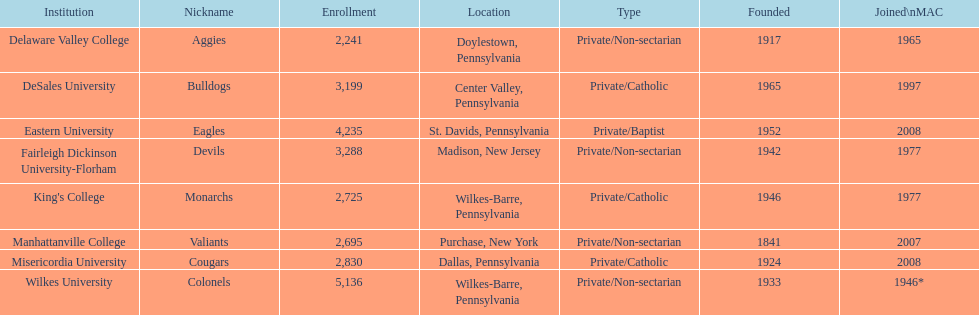Name each institution with enrollment numbers above 4,000? Eastern University, Wilkes University. Parse the full table. {'header': ['Institution', 'Nickname', 'Enrollment', 'Location', 'Type', 'Founded', 'Joined\\nMAC'], 'rows': [['Delaware Valley College', 'Aggies', '2,241', 'Doylestown, Pennsylvania', 'Private/Non-sectarian', '1917', '1965'], ['DeSales University', 'Bulldogs', '3,199', 'Center Valley, Pennsylvania', 'Private/Catholic', '1965', '1997'], ['Eastern University', 'Eagles', '4,235', 'St. Davids, Pennsylvania', 'Private/Baptist', '1952', '2008'], ['Fairleigh Dickinson University-Florham', 'Devils', '3,288', 'Madison, New Jersey', 'Private/Non-sectarian', '1942', '1977'], ["King's College", 'Monarchs', '2,725', 'Wilkes-Barre, Pennsylvania', 'Private/Catholic', '1946', '1977'], ['Manhattanville College', 'Valiants', '2,695', 'Purchase, New York', 'Private/Non-sectarian', '1841', '2007'], ['Misericordia University', 'Cougars', '2,830', 'Dallas, Pennsylvania', 'Private/Catholic', '1924', '2008'], ['Wilkes University', 'Colonels', '5,136', 'Wilkes-Barre, Pennsylvania', 'Private/Non-sectarian', '1933', '1946*']]} 